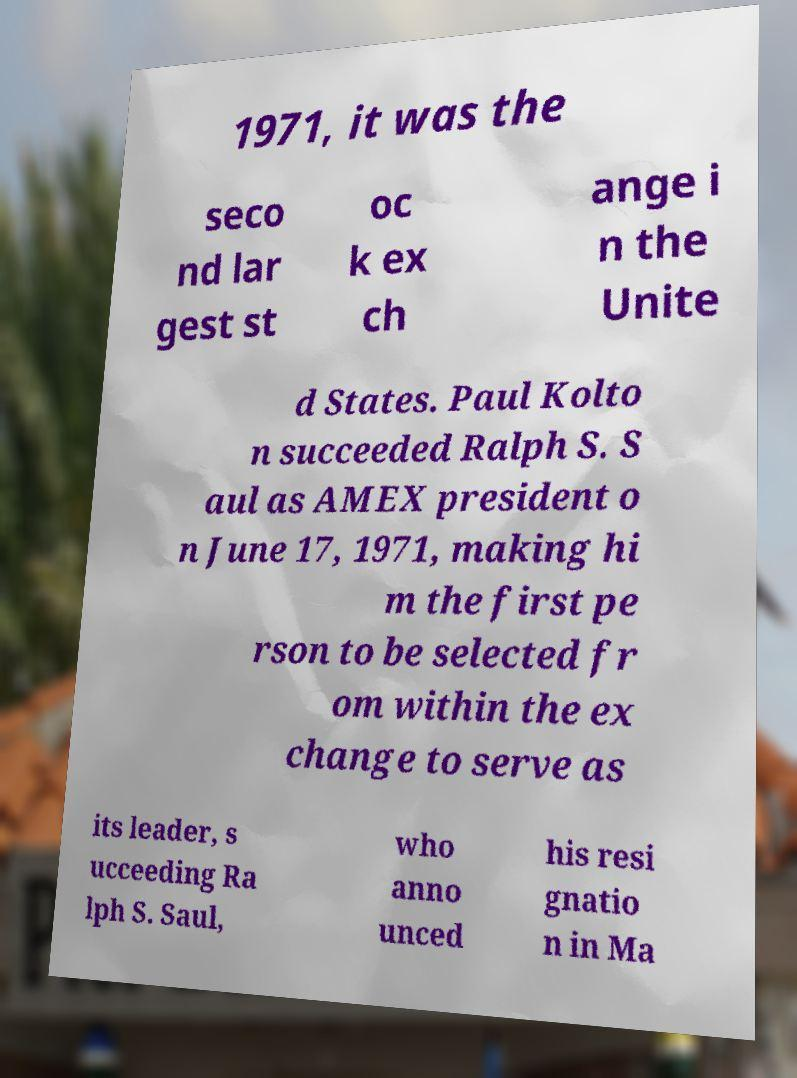Can you accurately transcribe the text from the provided image for me? 1971, it was the seco nd lar gest st oc k ex ch ange i n the Unite d States. Paul Kolto n succeeded Ralph S. S aul as AMEX president o n June 17, 1971, making hi m the first pe rson to be selected fr om within the ex change to serve as its leader, s ucceeding Ra lph S. Saul, who anno unced his resi gnatio n in Ma 